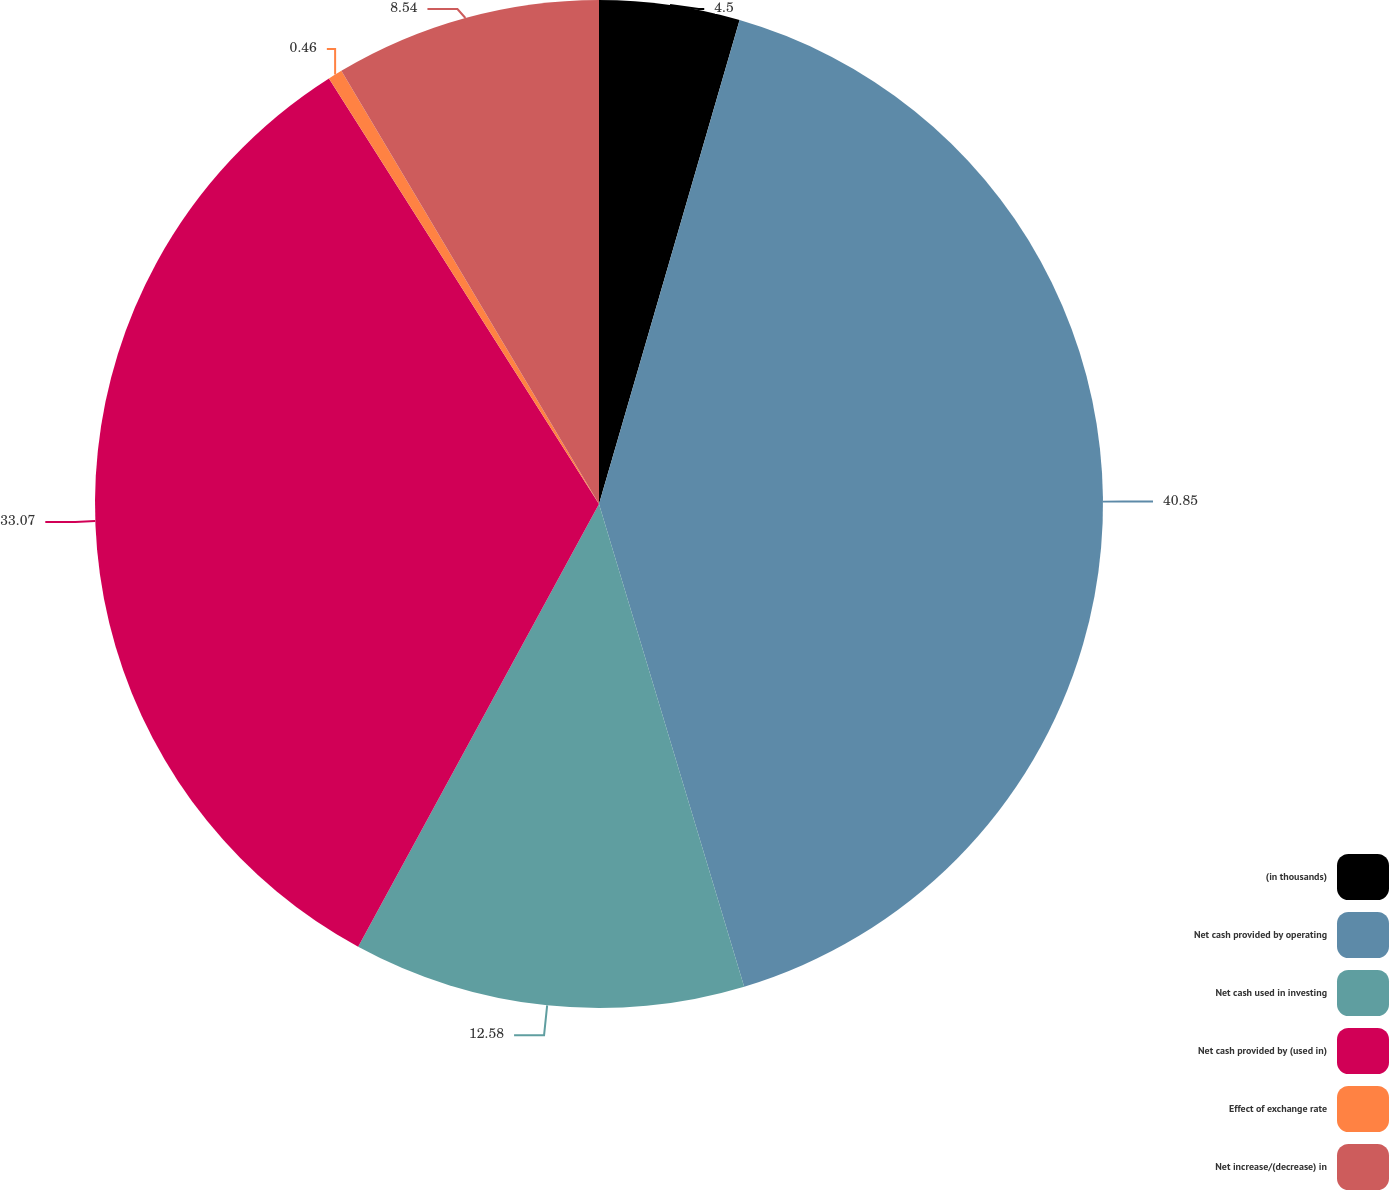Convert chart to OTSL. <chart><loc_0><loc_0><loc_500><loc_500><pie_chart><fcel>(in thousands)<fcel>Net cash provided by operating<fcel>Net cash used in investing<fcel>Net cash provided by (used in)<fcel>Effect of exchange rate<fcel>Net increase/(decrease) in<nl><fcel>4.5%<fcel>40.85%<fcel>12.58%<fcel>33.07%<fcel>0.46%<fcel>8.54%<nl></chart> 